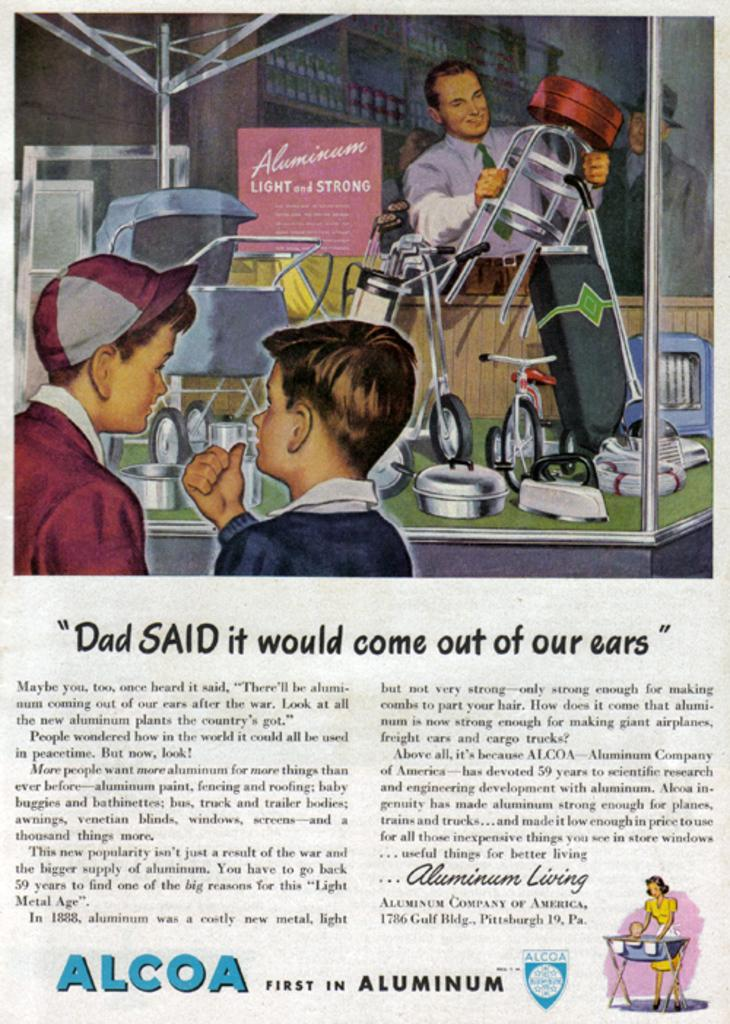How many people are present in the image? There are three people in the image. What can be seen besides the people in the image? There is a metal instrument and text visible in the image. What type of grain is being stored in the jail in the image? There is no grain or jail present in the image. How much butter is visible on the metal instrument in the image? There is no butter visible on the metal instrument in the image. 